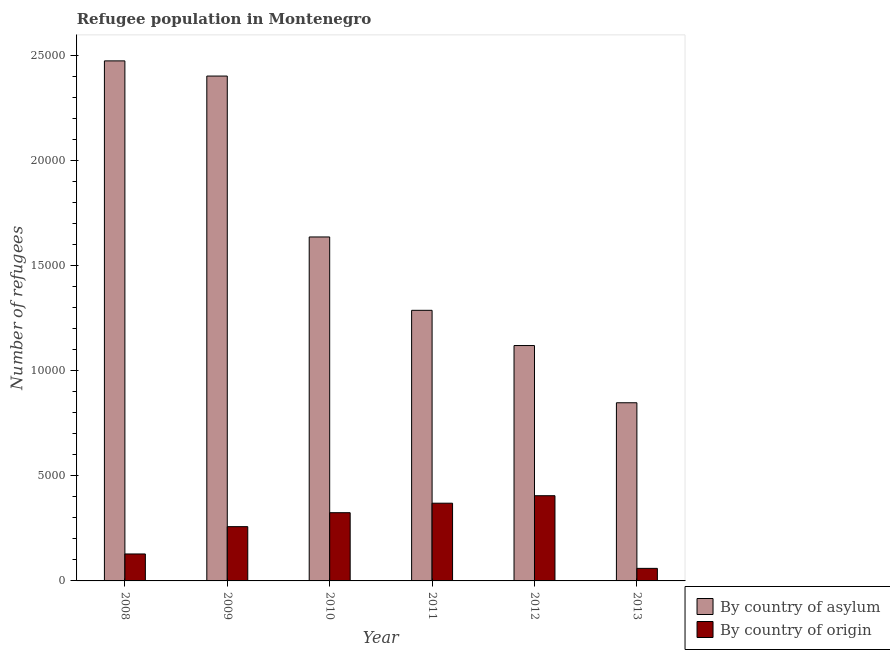How many bars are there on the 5th tick from the left?
Your response must be concise. 2. How many bars are there on the 6th tick from the right?
Make the answer very short. 2. What is the label of the 6th group of bars from the left?
Your response must be concise. 2013. What is the number of refugees by country of asylum in 2013?
Your answer should be very brief. 8476. Across all years, what is the maximum number of refugees by country of asylum?
Ensure brevity in your answer.  2.47e+04. Across all years, what is the minimum number of refugees by country of origin?
Your response must be concise. 597. In which year was the number of refugees by country of asylum maximum?
Your response must be concise. 2008. What is the total number of refugees by country of origin in the graph?
Offer a terse response. 1.55e+04. What is the difference between the number of refugees by country of asylum in 2008 and that in 2013?
Your response must be concise. 1.63e+04. What is the difference between the number of refugees by country of origin in 2009 and the number of refugees by country of asylum in 2008?
Your response must be concise. 1299. What is the average number of refugees by country of origin per year?
Offer a very short reply. 2576.67. In the year 2011, what is the difference between the number of refugees by country of asylum and number of refugees by country of origin?
Your response must be concise. 0. What is the ratio of the number of refugees by country of origin in 2009 to that in 2013?
Give a very brief answer. 4.32. Is the difference between the number of refugees by country of asylum in 2008 and 2012 greater than the difference between the number of refugees by country of origin in 2008 and 2012?
Your response must be concise. No. What is the difference between the highest and the second highest number of refugees by country of origin?
Your response must be concise. 356. What is the difference between the highest and the lowest number of refugees by country of origin?
Your answer should be very brief. 3457. Is the sum of the number of refugees by country of asylum in 2008 and 2010 greater than the maximum number of refugees by country of origin across all years?
Give a very brief answer. Yes. What does the 1st bar from the left in 2012 represents?
Your answer should be very brief. By country of asylum. What does the 1st bar from the right in 2011 represents?
Provide a short and direct response. By country of origin. How many years are there in the graph?
Your answer should be very brief. 6. Are the values on the major ticks of Y-axis written in scientific E-notation?
Offer a terse response. No. Does the graph contain grids?
Offer a terse response. No. Where does the legend appear in the graph?
Provide a succinct answer. Bottom right. How are the legend labels stacked?
Offer a terse response. Vertical. What is the title of the graph?
Offer a very short reply. Refugee population in Montenegro. Does "State government" appear as one of the legend labels in the graph?
Keep it short and to the point. No. What is the label or title of the X-axis?
Offer a very short reply. Year. What is the label or title of the Y-axis?
Offer a very short reply. Number of refugees. What is the Number of refugees in By country of asylum in 2008?
Ensure brevity in your answer.  2.47e+04. What is the Number of refugees in By country of origin in 2008?
Give a very brief answer. 1283. What is the Number of refugees of By country of asylum in 2009?
Your answer should be very brief. 2.40e+04. What is the Number of refugees of By country of origin in 2009?
Make the answer very short. 2582. What is the Number of refugees in By country of asylum in 2010?
Offer a terse response. 1.64e+04. What is the Number of refugees in By country of origin in 2010?
Ensure brevity in your answer.  3246. What is the Number of refugees of By country of asylum in 2011?
Provide a short and direct response. 1.29e+04. What is the Number of refugees in By country of origin in 2011?
Offer a very short reply. 3698. What is the Number of refugees of By country of asylum in 2012?
Make the answer very short. 1.12e+04. What is the Number of refugees of By country of origin in 2012?
Ensure brevity in your answer.  4054. What is the Number of refugees of By country of asylum in 2013?
Your response must be concise. 8476. What is the Number of refugees in By country of origin in 2013?
Provide a short and direct response. 597. Across all years, what is the maximum Number of refugees in By country of asylum?
Your response must be concise. 2.47e+04. Across all years, what is the maximum Number of refugees in By country of origin?
Offer a very short reply. 4054. Across all years, what is the minimum Number of refugees in By country of asylum?
Offer a very short reply. 8476. Across all years, what is the minimum Number of refugees of By country of origin?
Offer a terse response. 597. What is the total Number of refugees of By country of asylum in the graph?
Offer a terse response. 9.77e+04. What is the total Number of refugees in By country of origin in the graph?
Ensure brevity in your answer.  1.55e+04. What is the difference between the Number of refugees of By country of asylum in 2008 and that in 2009?
Your response must be concise. 722. What is the difference between the Number of refugees in By country of origin in 2008 and that in 2009?
Your response must be concise. -1299. What is the difference between the Number of refugees in By country of asylum in 2008 and that in 2010?
Offer a very short reply. 8377. What is the difference between the Number of refugees of By country of origin in 2008 and that in 2010?
Make the answer very short. -1963. What is the difference between the Number of refugees of By country of asylum in 2008 and that in 2011?
Offer a very short reply. 1.19e+04. What is the difference between the Number of refugees of By country of origin in 2008 and that in 2011?
Your answer should be compact. -2415. What is the difference between the Number of refugees in By country of asylum in 2008 and that in 2012?
Keep it short and to the point. 1.35e+04. What is the difference between the Number of refugees of By country of origin in 2008 and that in 2012?
Provide a short and direct response. -2771. What is the difference between the Number of refugees of By country of asylum in 2008 and that in 2013?
Keep it short and to the point. 1.63e+04. What is the difference between the Number of refugees in By country of origin in 2008 and that in 2013?
Keep it short and to the point. 686. What is the difference between the Number of refugees in By country of asylum in 2009 and that in 2010?
Provide a succinct answer. 7655. What is the difference between the Number of refugees in By country of origin in 2009 and that in 2010?
Give a very brief answer. -664. What is the difference between the Number of refugees in By country of asylum in 2009 and that in 2011?
Your response must be concise. 1.11e+04. What is the difference between the Number of refugees of By country of origin in 2009 and that in 2011?
Your answer should be compact. -1116. What is the difference between the Number of refugees of By country of asylum in 2009 and that in 2012?
Offer a very short reply. 1.28e+04. What is the difference between the Number of refugees in By country of origin in 2009 and that in 2012?
Ensure brevity in your answer.  -1472. What is the difference between the Number of refugees in By country of asylum in 2009 and that in 2013?
Ensure brevity in your answer.  1.55e+04. What is the difference between the Number of refugees in By country of origin in 2009 and that in 2013?
Ensure brevity in your answer.  1985. What is the difference between the Number of refugees of By country of asylum in 2010 and that in 2011?
Ensure brevity in your answer.  3490. What is the difference between the Number of refugees in By country of origin in 2010 and that in 2011?
Keep it short and to the point. -452. What is the difference between the Number of refugees of By country of asylum in 2010 and that in 2012?
Your response must be concise. 5166. What is the difference between the Number of refugees of By country of origin in 2010 and that in 2012?
Provide a short and direct response. -808. What is the difference between the Number of refugees of By country of asylum in 2010 and that in 2013?
Ensure brevity in your answer.  7888. What is the difference between the Number of refugees in By country of origin in 2010 and that in 2013?
Give a very brief answer. 2649. What is the difference between the Number of refugees of By country of asylum in 2011 and that in 2012?
Ensure brevity in your answer.  1676. What is the difference between the Number of refugees in By country of origin in 2011 and that in 2012?
Make the answer very short. -356. What is the difference between the Number of refugees in By country of asylum in 2011 and that in 2013?
Ensure brevity in your answer.  4398. What is the difference between the Number of refugees of By country of origin in 2011 and that in 2013?
Your answer should be compact. 3101. What is the difference between the Number of refugees of By country of asylum in 2012 and that in 2013?
Your response must be concise. 2722. What is the difference between the Number of refugees in By country of origin in 2012 and that in 2013?
Your answer should be very brief. 3457. What is the difference between the Number of refugees in By country of asylum in 2008 and the Number of refugees in By country of origin in 2009?
Keep it short and to the point. 2.22e+04. What is the difference between the Number of refugees in By country of asylum in 2008 and the Number of refugees in By country of origin in 2010?
Offer a terse response. 2.15e+04. What is the difference between the Number of refugees in By country of asylum in 2008 and the Number of refugees in By country of origin in 2011?
Offer a very short reply. 2.10e+04. What is the difference between the Number of refugees in By country of asylum in 2008 and the Number of refugees in By country of origin in 2012?
Make the answer very short. 2.07e+04. What is the difference between the Number of refugees in By country of asylum in 2008 and the Number of refugees in By country of origin in 2013?
Offer a very short reply. 2.41e+04. What is the difference between the Number of refugees of By country of asylum in 2009 and the Number of refugees of By country of origin in 2010?
Give a very brief answer. 2.08e+04. What is the difference between the Number of refugees in By country of asylum in 2009 and the Number of refugees in By country of origin in 2011?
Provide a succinct answer. 2.03e+04. What is the difference between the Number of refugees of By country of asylum in 2009 and the Number of refugees of By country of origin in 2012?
Keep it short and to the point. 2.00e+04. What is the difference between the Number of refugees in By country of asylum in 2009 and the Number of refugees in By country of origin in 2013?
Your response must be concise. 2.34e+04. What is the difference between the Number of refugees in By country of asylum in 2010 and the Number of refugees in By country of origin in 2011?
Your answer should be very brief. 1.27e+04. What is the difference between the Number of refugees of By country of asylum in 2010 and the Number of refugees of By country of origin in 2012?
Make the answer very short. 1.23e+04. What is the difference between the Number of refugees in By country of asylum in 2010 and the Number of refugees in By country of origin in 2013?
Offer a terse response. 1.58e+04. What is the difference between the Number of refugees in By country of asylum in 2011 and the Number of refugees in By country of origin in 2012?
Your answer should be compact. 8820. What is the difference between the Number of refugees of By country of asylum in 2011 and the Number of refugees of By country of origin in 2013?
Provide a short and direct response. 1.23e+04. What is the difference between the Number of refugees in By country of asylum in 2012 and the Number of refugees in By country of origin in 2013?
Your answer should be compact. 1.06e+04. What is the average Number of refugees in By country of asylum per year?
Give a very brief answer. 1.63e+04. What is the average Number of refugees in By country of origin per year?
Offer a terse response. 2576.67. In the year 2008, what is the difference between the Number of refugees of By country of asylum and Number of refugees of By country of origin?
Ensure brevity in your answer.  2.35e+04. In the year 2009, what is the difference between the Number of refugees of By country of asylum and Number of refugees of By country of origin?
Ensure brevity in your answer.  2.14e+04. In the year 2010, what is the difference between the Number of refugees in By country of asylum and Number of refugees in By country of origin?
Ensure brevity in your answer.  1.31e+04. In the year 2011, what is the difference between the Number of refugees of By country of asylum and Number of refugees of By country of origin?
Offer a very short reply. 9176. In the year 2012, what is the difference between the Number of refugees of By country of asylum and Number of refugees of By country of origin?
Give a very brief answer. 7144. In the year 2013, what is the difference between the Number of refugees of By country of asylum and Number of refugees of By country of origin?
Provide a short and direct response. 7879. What is the ratio of the Number of refugees in By country of asylum in 2008 to that in 2009?
Offer a terse response. 1.03. What is the ratio of the Number of refugees of By country of origin in 2008 to that in 2009?
Make the answer very short. 0.5. What is the ratio of the Number of refugees of By country of asylum in 2008 to that in 2010?
Keep it short and to the point. 1.51. What is the ratio of the Number of refugees of By country of origin in 2008 to that in 2010?
Your response must be concise. 0.4. What is the ratio of the Number of refugees of By country of asylum in 2008 to that in 2011?
Keep it short and to the point. 1.92. What is the ratio of the Number of refugees of By country of origin in 2008 to that in 2011?
Provide a short and direct response. 0.35. What is the ratio of the Number of refugees in By country of asylum in 2008 to that in 2012?
Ensure brevity in your answer.  2.21. What is the ratio of the Number of refugees of By country of origin in 2008 to that in 2012?
Keep it short and to the point. 0.32. What is the ratio of the Number of refugees of By country of asylum in 2008 to that in 2013?
Provide a succinct answer. 2.92. What is the ratio of the Number of refugees in By country of origin in 2008 to that in 2013?
Keep it short and to the point. 2.15. What is the ratio of the Number of refugees of By country of asylum in 2009 to that in 2010?
Your response must be concise. 1.47. What is the ratio of the Number of refugees in By country of origin in 2009 to that in 2010?
Give a very brief answer. 0.8. What is the ratio of the Number of refugees in By country of asylum in 2009 to that in 2011?
Provide a succinct answer. 1.87. What is the ratio of the Number of refugees in By country of origin in 2009 to that in 2011?
Your response must be concise. 0.7. What is the ratio of the Number of refugees in By country of asylum in 2009 to that in 2012?
Your answer should be very brief. 2.14. What is the ratio of the Number of refugees of By country of origin in 2009 to that in 2012?
Your answer should be very brief. 0.64. What is the ratio of the Number of refugees of By country of asylum in 2009 to that in 2013?
Keep it short and to the point. 2.83. What is the ratio of the Number of refugees of By country of origin in 2009 to that in 2013?
Ensure brevity in your answer.  4.33. What is the ratio of the Number of refugees in By country of asylum in 2010 to that in 2011?
Offer a very short reply. 1.27. What is the ratio of the Number of refugees in By country of origin in 2010 to that in 2011?
Give a very brief answer. 0.88. What is the ratio of the Number of refugees of By country of asylum in 2010 to that in 2012?
Your answer should be compact. 1.46. What is the ratio of the Number of refugees in By country of origin in 2010 to that in 2012?
Offer a very short reply. 0.8. What is the ratio of the Number of refugees in By country of asylum in 2010 to that in 2013?
Ensure brevity in your answer.  1.93. What is the ratio of the Number of refugees in By country of origin in 2010 to that in 2013?
Offer a terse response. 5.44. What is the ratio of the Number of refugees in By country of asylum in 2011 to that in 2012?
Your answer should be very brief. 1.15. What is the ratio of the Number of refugees in By country of origin in 2011 to that in 2012?
Offer a terse response. 0.91. What is the ratio of the Number of refugees in By country of asylum in 2011 to that in 2013?
Offer a very short reply. 1.52. What is the ratio of the Number of refugees in By country of origin in 2011 to that in 2013?
Keep it short and to the point. 6.19. What is the ratio of the Number of refugees of By country of asylum in 2012 to that in 2013?
Give a very brief answer. 1.32. What is the ratio of the Number of refugees of By country of origin in 2012 to that in 2013?
Offer a very short reply. 6.79. What is the difference between the highest and the second highest Number of refugees of By country of asylum?
Provide a short and direct response. 722. What is the difference between the highest and the second highest Number of refugees of By country of origin?
Your answer should be very brief. 356. What is the difference between the highest and the lowest Number of refugees of By country of asylum?
Offer a terse response. 1.63e+04. What is the difference between the highest and the lowest Number of refugees in By country of origin?
Offer a very short reply. 3457. 